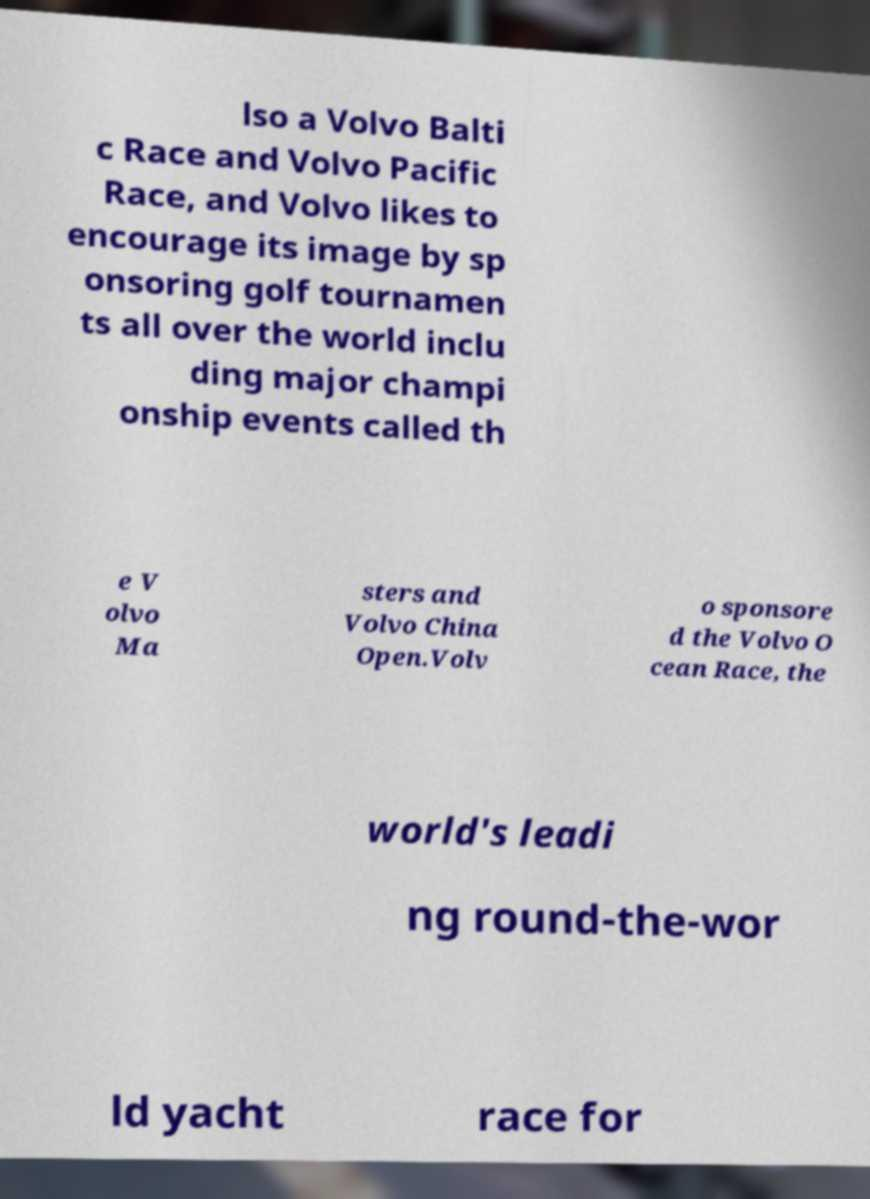There's text embedded in this image that I need extracted. Can you transcribe it verbatim? lso a Volvo Balti c Race and Volvo Pacific Race, and Volvo likes to encourage its image by sp onsoring golf tournamen ts all over the world inclu ding major champi onship events called th e V olvo Ma sters and Volvo China Open.Volv o sponsore d the Volvo O cean Race, the world's leadi ng round-the-wor ld yacht race for 